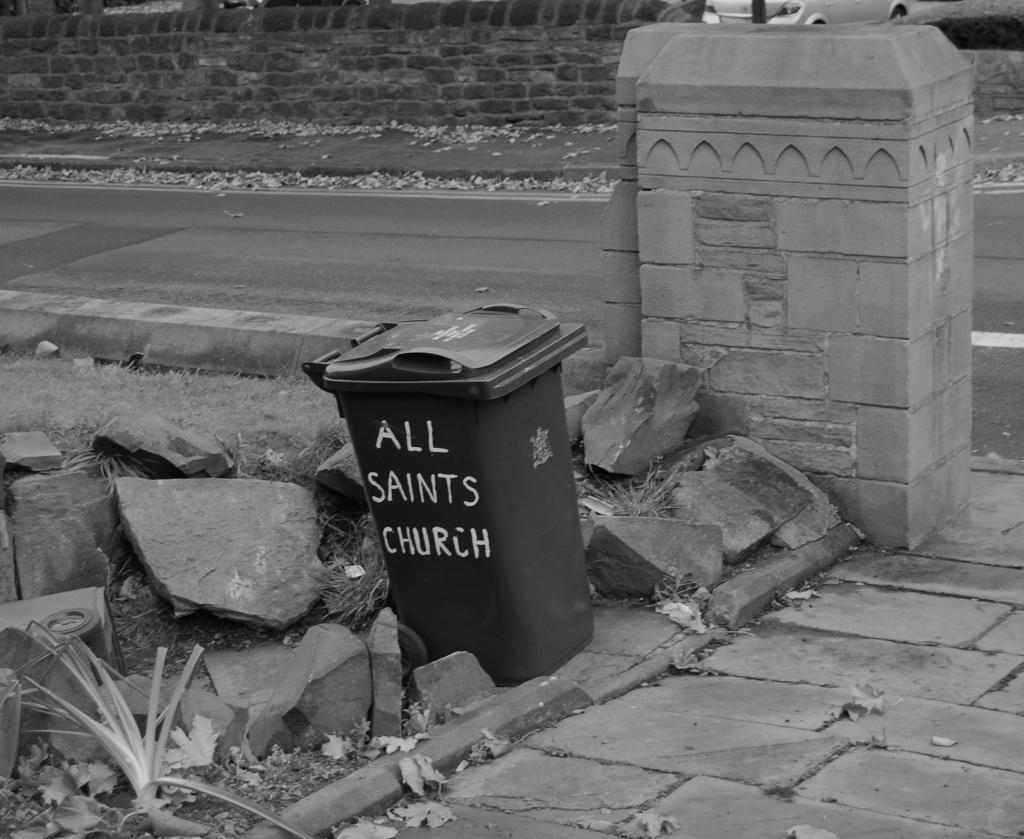<image>
Offer a succinct explanation of the picture presented. A garbage can that says "All Saints Church" sits in a pile of rocks. 